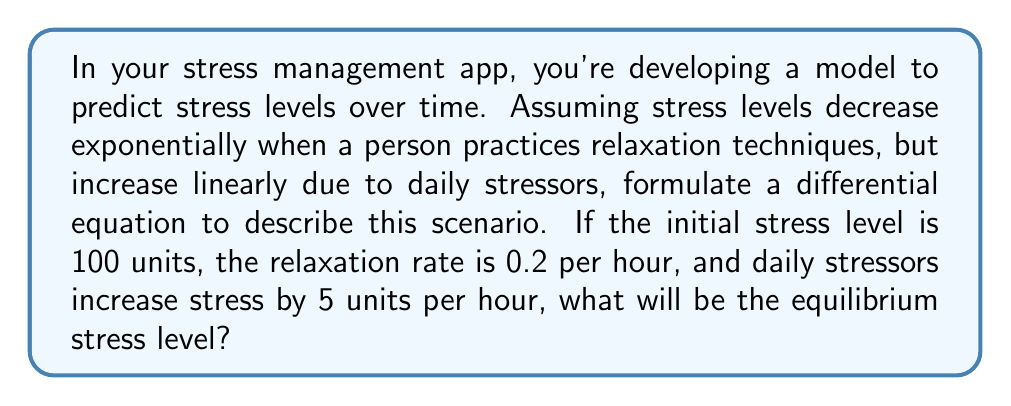Solve this math problem. Let's approach this step-by-step:

1) Let $S(t)$ be the stress level at time $t$ (in hours).

2) The rate of change of stress can be modeled as:
   $$\frac{dS}{dt} = -0.2S + 5$$
   
   Where:
   - $-0.2S$ represents the exponential decrease due to relaxation
   - $+5$ represents the linear increase due to daily stressors

3) To find the equilibrium stress level, we set $\frac{dS}{dt} = 0$:
   $$0 = -0.2S + 5$$

4) Solve for $S$:
   $$0.2S = 5$$
   $$S = \frac{5}{0.2} = 25$$

5) Therefore, the equilibrium stress level is 25 units.

This means that over time, regardless of the initial stress level, the stress will approach and stabilize at 25 units if these conditions remain constant.
Answer: 25 units 